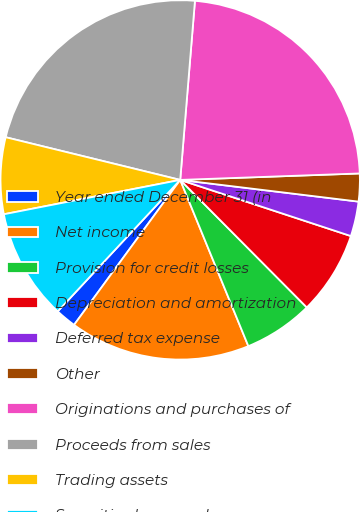Convert chart to OTSL. <chart><loc_0><loc_0><loc_500><loc_500><pie_chart><fcel>Year ended December 31 (in<fcel>Net income<fcel>Provision for credit losses<fcel>Depreciation and amortization<fcel>Deferred tax expense<fcel>Other<fcel>Originations and purchases of<fcel>Proceeds from sales<fcel>Trading assets<fcel>Securities borrowed<nl><fcel>1.88%<fcel>16.25%<fcel>6.25%<fcel>7.5%<fcel>3.13%<fcel>2.5%<fcel>23.12%<fcel>22.49%<fcel>6.88%<fcel>10.0%<nl></chart> 